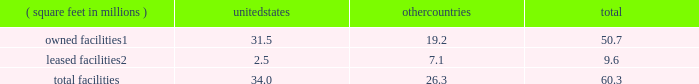There are inherent limitations on the effectiveness of our controls .
We do not expect that our disclosure controls or our internal control over financial reporting will prevent or detect all errors and all fraud .
A control system , no matter how well-designed and operated , can provide only reasonable , not absolute , assurance that the control system 2019s objectives will be met .
The design of a control system must reflect the fact that resource constraints exist , and the benefits of controls must be considered relative to their costs .
Further , because of the inherent limitations in all control systems , no evaluation of controls can provide absolute assurance that misstatements due to error or fraud will not occur or that all control issues and instances of fraud , if any , have been detected .
The design of any system of controls is based in part on certain assumptions about the likelihood of future events , and there can be no assurance that any design will succeed in achieving its stated goals under all potential future conditions .
Projections of any evaluation of the effectiveness of controls to future periods are subject to risks .
Over time , controls may become inadequate due to changes in conditions or deterioration in the degree of compliance with policies or procedures .
If our controls become inadequate , we could fail to meet our financial reporting obligations , our reputation may be adversely affected , our business and operating results could be harmed , and the market price of our stock could decline .
Item 1b .
Unresolved staff comments not applicable .
Item 2 .
Properties as of december 31 , 2016 , our major facilities consisted of : ( square feet in millions ) united states countries total owned facilities1 .
31.5 19.2 50.7 leased facilities2 .
2.5 7.1 9.6 .
1 leases and municipal grants on portions of the land used for these facilities expire on varying dates through 2109 .
2 leases expire on varying dates through 2058 and generally include renewals at our option .
Our principal executive offices are located in the u.s .
And the majority of our wafer manufacturing activities in 2016 were also located in the u.s .
One of our arizona wafer fabrication facilities is currently on hold and held in a safe state , and we are reserving the building for additional capacity and future technologies .
Incremental construction and equipment installation are required to ready the facility for its intended use .
For more information on our wafer fabrication and our assembly and test facilities , see 201cmanufacturing and assembly and test 201d in part i , item 1 of this form 10-k .
We believe that the facilities described above are suitable and adequate for our present purposes and that the productive capacity in our facilities is substantially being utilized or we have plans to utilize it .
We do not identify or allocate assets by operating segment .
For information on net property , plant and equipment by country , see 201cnote 4 : operating segments and geographic information 201d in part ii , item 8 of this form 10-k .
Item 3 .
Legal proceedings for a discussion of legal proceedings , see 201cnote 20 : commitments and contingencies 201d in part ii , item 8 of this form 10-k .
Item 4 .
Mine safety disclosures not applicable. .
As of december 31 , 2016 what percentage by square feet of major facilities are owned? 
Computations: (50.7 / 60.3)
Answer: 0.8408. 